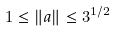<formula> <loc_0><loc_0><loc_500><loc_500>1 \leq { \| { a } \| } \leq { 3 ^ { 1 / 2 } }</formula> 